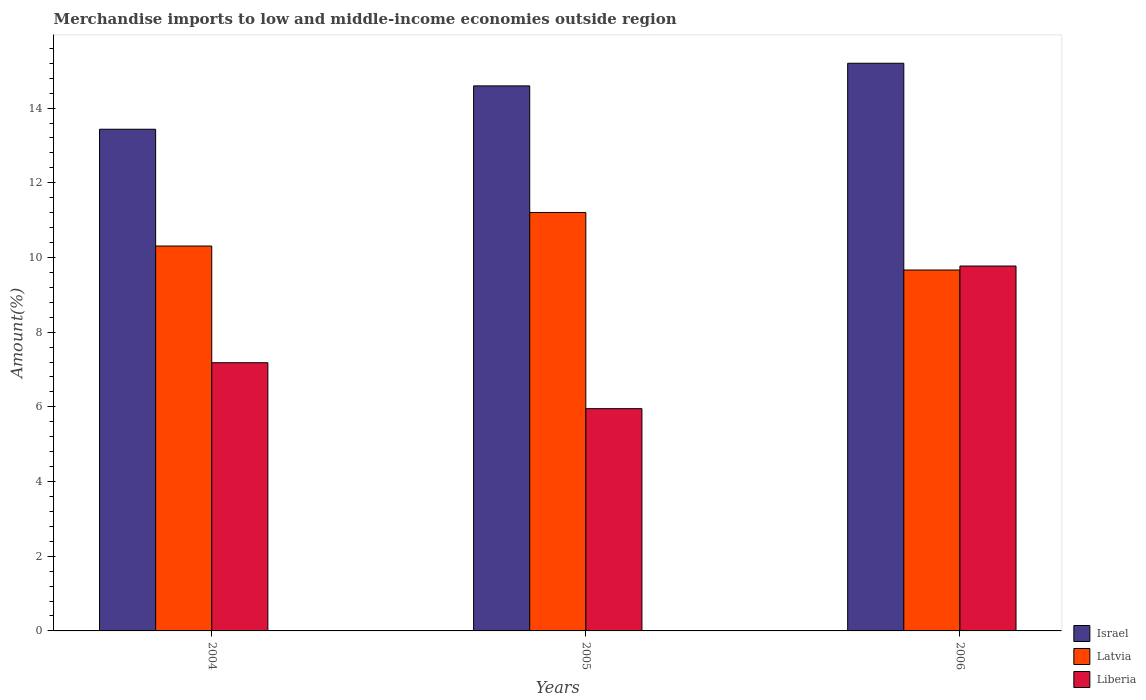In how many cases, is the number of bars for a given year not equal to the number of legend labels?
Provide a short and direct response. 0. What is the percentage of amount earned from merchandise imports in Latvia in 2006?
Offer a terse response. 9.66. Across all years, what is the maximum percentage of amount earned from merchandise imports in Latvia?
Your answer should be compact. 11.21. Across all years, what is the minimum percentage of amount earned from merchandise imports in Latvia?
Your answer should be compact. 9.66. In which year was the percentage of amount earned from merchandise imports in Israel maximum?
Provide a short and direct response. 2006. In which year was the percentage of amount earned from merchandise imports in Liberia minimum?
Keep it short and to the point. 2005. What is the total percentage of amount earned from merchandise imports in Liberia in the graph?
Make the answer very short. 22.91. What is the difference between the percentage of amount earned from merchandise imports in Liberia in 2004 and that in 2006?
Ensure brevity in your answer.  -2.59. What is the difference between the percentage of amount earned from merchandise imports in Latvia in 2005 and the percentage of amount earned from merchandise imports in Israel in 2004?
Provide a succinct answer. -2.23. What is the average percentage of amount earned from merchandise imports in Liberia per year?
Offer a terse response. 7.64. In the year 2005, what is the difference between the percentage of amount earned from merchandise imports in Israel and percentage of amount earned from merchandise imports in Liberia?
Your answer should be very brief. 8.64. In how many years, is the percentage of amount earned from merchandise imports in Israel greater than 3.2 %?
Your response must be concise. 3. What is the ratio of the percentage of amount earned from merchandise imports in Liberia in 2004 to that in 2005?
Your answer should be compact. 1.21. Is the difference between the percentage of amount earned from merchandise imports in Israel in 2005 and 2006 greater than the difference between the percentage of amount earned from merchandise imports in Liberia in 2005 and 2006?
Provide a short and direct response. Yes. What is the difference between the highest and the second highest percentage of amount earned from merchandise imports in Liberia?
Provide a succinct answer. 2.59. What is the difference between the highest and the lowest percentage of amount earned from merchandise imports in Israel?
Provide a succinct answer. 1.77. In how many years, is the percentage of amount earned from merchandise imports in Israel greater than the average percentage of amount earned from merchandise imports in Israel taken over all years?
Your answer should be very brief. 2. What does the 1st bar from the left in 2006 represents?
Make the answer very short. Israel. What does the 3rd bar from the right in 2004 represents?
Offer a terse response. Israel. Is it the case that in every year, the sum of the percentage of amount earned from merchandise imports in Latvia and percentage of amount earned from merchandise imports in Liberia is greater than the percentage of amount earned from merchandise imports in Israel?
Your response must be concise. Yes. Are all the bars in the graph horizontal?
Make the answer very short. No. Are the values on the major ticks of Y-axis written in scientific E-notation?
Make the answer very short. No. Does the graph contain any zero values?
Keep it short and to the point. No. Does the graph contain grids?
Offer a terse response. No. How many legend labels are there?
Ensure brevity in your answer.  3. How are the legend labels stacked?
Your answer should be very brief. Vertical. What is the title of the graph?
Provide a succinct answer. Merchandise imports to low and middle-income economies outside region. What is the label or title of the X-axis?
Ensure brevity in your answer.  Years. What is the label or title of the Y-axis?
Your answer should be compact. Amount(%). What is the Amount(%) of Israel in 2004?
Make the answer very short. 13.43. What is the Amount(%) of Latvia in 2004?
Keep it short and to the point. 10.31. What is the Amount(%) of Liberia in 2004?
Ensure brevity in your answer.  7.18. What is the Amount(%) of Israel in 2005?
Offer a very short reply. 14.6. What is the Amount(%) of Latvia in 2005?
Provide a succinct answer. 11.21. What is the Amount(%) in Liberia in 2005?
Keep it short and to the point. 5.95. What is the Amount(%) of Israel in 2006?
Give a very brief answer. 15.2. What is the Amount(%) of Latvia in 2006?
Ensure brevity in your answer.  9.66. What is the Amount(%) in Liberia in 2006?
Offer a very short reply. 9.77. Across all years, what is the maximum Amount(%) in Israel?
Your response must be concise. 15.2. Across all years, what is the maximum Amount(%) in Latvia?
Your answer should be compact. 11.21. Across all years, what is the maximum Amount(%) in Liberia?
Keep it short and to the point. 9.77. Across all years, what is the minimum Amount(%) in Israel?
Your answer should be compact. 13.43. Across all years, what is the minimum Amount(%) of Latvia?
Offer a terse response. 9.66. Across all years, what is the minimum Amount(%) of Liberia?
Keep it short and to the point. 5.95. What is the total Amount(%) of Israel in the graph?
Offer a very short reply. 43.23. What is the total Amount(%) in Latvia in the graph?
Offer a very short reply. 31.18. What is the total Amount(%) in Liberia in the graph?
Offer a very short reply. 22.91. What is the difference between the Amount(%) in Israel in 2004 and that in 2005?
Offer a very short reply. -1.16. What is the difference between the Amount(%) of Latvia in 2004 and that in 2005?
Provide a short and direct response. -0.9. What is the difference between the Amount(%) in Liberia in 2004 and that in 2005?
Provide a succinct answer. 1.23. What is the difference between the Amount(%) of Israel in 2004 and that in 2006?
Offer a terse response. -1.77. What is the difference between the Amount(%) in Latvia in 2004 and that in 2006?
Offer a terse response. 0.64. What is the difference between the Amount(%) of Liberia in 2004 and that in 2006?
Your answer should be very brief. -2.59. What is the difference between the Amount(%) of Israel in 2005 and that in 2006?
Your response must be concise. -0.61. What is the difference between the Amount(%) of Latvia in 2005 and that in 2006?
Offer a very short reply. 1.54. What is the difference between the Amount(%) in Liberia in 2005 and that in 2006?
Your answer should be compact. -3.82. What is the difference between the Amount(%) of Israel in 2004 and the Amount(%) of Latvia in 2005?
Your response must be concise. 2.23. What is the difference between the Amount(%) in Israel in 2004 and the Amount(%) in Liberia in 2005?
Your response must be concise. 7.48. What is the difference between the Amount(%) in Latvia in 2004 and the Amount(%) in Liberia in 2005?
Your response must be concise. 4.36. What is the difference between the Amount(%) in Israel in 2004 and the Amount(%) in Latvia in 2006?
Keep it short and to the point. 3.77. What is the difference between the Amount(%) in Israel in 2004 and the Amount(%) in Liberia in 2006?
Keep it short and to the point. 3.66. What is the difference between the Amount(%) in Latvia in 2004 and the Amount(%) in Liberia in 2006?
Your answer should be compact. 0.54. What is the difference between the Amount(%) of Israel in 2005 and the Amount(%) of Latvia in 2006?
Your answer should be very brief. 4.93. What is the difference between the Amount(%) of Israel in 2005 and the Amount(%) of Liberia in 2006?
Keep it short and to the point. 4.82. What is the difference between the Amount(%) of Latvia in 2005 and the Amount(%) of Liberia in 2006?
Your answer should be very brief. 1.43. What is the average Amount(%) in Israel per year?
Provide a succinct answer. 14.41. What is the average Amount(%) of Latvia per year?
Keep it short and to the point. 10.39. What is the average Amount(%) in Liberia per year?
Give a very brief answer. 7.64. In the year 2004, what is the difference between the Amount(%) of Israel and Amount(%) of Latvia?
Your answer should be very brief. 3.13. In the year 2004, what is the difference between the Amount(%) of Israel and Amount(%) of Liberia?
Make the answer very short. 6.25. In the year 2004, what is the difference between the Amount(%) of Latvia and Amount(%) of Liberia?
Your answer should be compact. 3.12. In the year 2005, what is the difference between the Amount(%) in Israel and Amount(%) in Latvia?
Make the answer very short. 3.39. In the year 2005, what is the difference between the Amount(%) in Israel and Amount(%) in Liberia?
Your answer should be very brief. 8.64. In the year 2005, what is the difference between the Amount(%) in Latvia and Amount(%) in Liberia?
Offer a terse response. 5.25. In the year 2006, what is the difference between the Amount(%) in Israel and Amount(%) in Latvia?
Provide a succinct answer. 5.54. In the year 2006, what is the difference between the Amount(%) in Israel and Amount(%) in Liberia?
Your response must be concise. 5.43. In the year 2006, what is the difference between the Amount(%) in Latvia and Amount(%) in Liberia?
Ensure brevity in your answer.  -0.11. What is the ratio of the Amount(%) in Israel in 2004 to that in 2005?
Offer a very short reply. 0.92. What is the ratio of the Amount(%) in Latvia in 2004 to that in 2005?
Your answer should be compact. 0.92. What is the ratio of the Amount(%) of Liberia in 2004 to that in 2005?
Provide a short and direct response. 1.21. What is the ratio of the Amount(%) in Israel in 2004 to that in 2006?
Offer a terse response. 0.88. What is the ratio of the Amount(%) in Latvia in 2004 to that in 2006?
Provide a succinct answer. 1.07. What is the ratio of the Amount(%) of Liberia in 2004 to that in 2006?
Offer a terse response. 0.73. What is the ratio of the Amount(%) of Israel in 2005 to that in 2006?
Your answer should be very brief. 0.96. What is the ratio of the Amount(%) of Latvia in 2005 to that in 2006?
Provide a short and direct response. 1.16. What is the ratio of the Amount(%) of Liberia in 2005 to that in 2006?
Ensure brevity in your answer.  0.61. What is the difference between the highest and the second highest Amount(%) of Israel?
Your answer should be very brief. 0.61. What is the difference between the highest and the second highest Amount(%) in Latvia?
Offer a terse response. 0.9. What is the difference between the highest and the second highest Amount(%) in Liberia?
Keep it short and to the point. 2.59. What is the difference between the highest and the lowest Amount(%) of Israel?
Your answer should be very brief. 1.77. What is the difference between the highest and the lowest Amount(%) of Latvia?
Your answer should be compact. 1.54. What is the difference between the highest and the lowest Amount(%) in Liberia?
Offer a terse response. 3.82. 